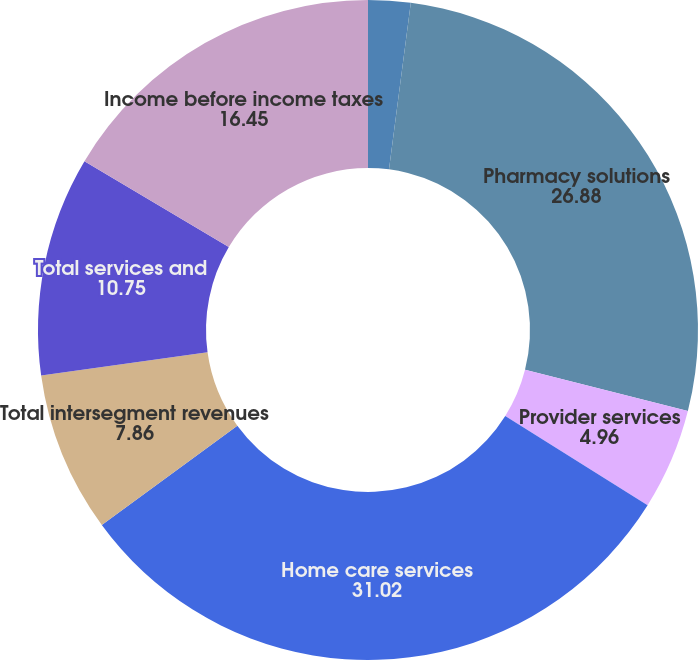Convert chart to OTSL. <chart><loc_0><loc_0><loc_500><loc_500><pie_chart><fcel>Integrated wellness services<fcel>Pharmacy solutions<fcel>Provider services<fcel>Home care services<fcel>Total intersegment revenues<fcel>Total services and<fcel>Income before income taxes<nl><fcel>2.07%<fcel>26.88%<fcel>4.96%<fcel>31.02%<fcel>7.86%<fcel>10.75%<fcel>16.45%<nl></chart> 